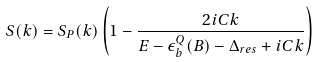Convert formula to latex. <formula><loc_0><loc_0><loc_500><loc_500>S ( k ) = S _ { P } ( k ) \left ( 1 - \frac { 2 i C k } { E - \epsilon _ { b } ^ { Q } ( B ) - \Delta _ { r e s } + i C k } \right )</formula> 